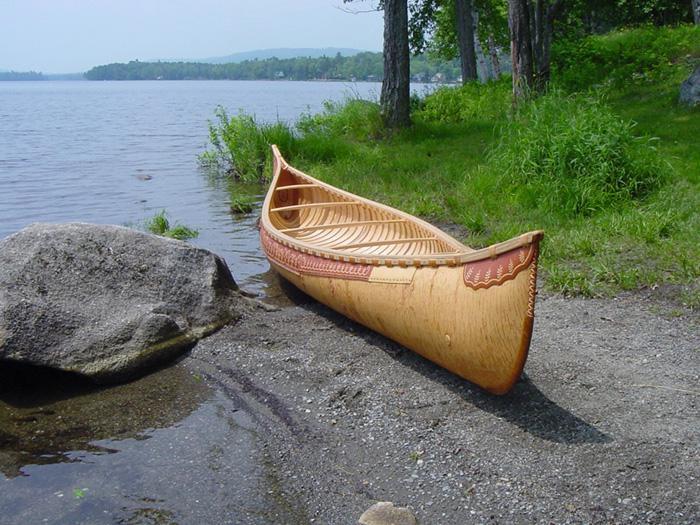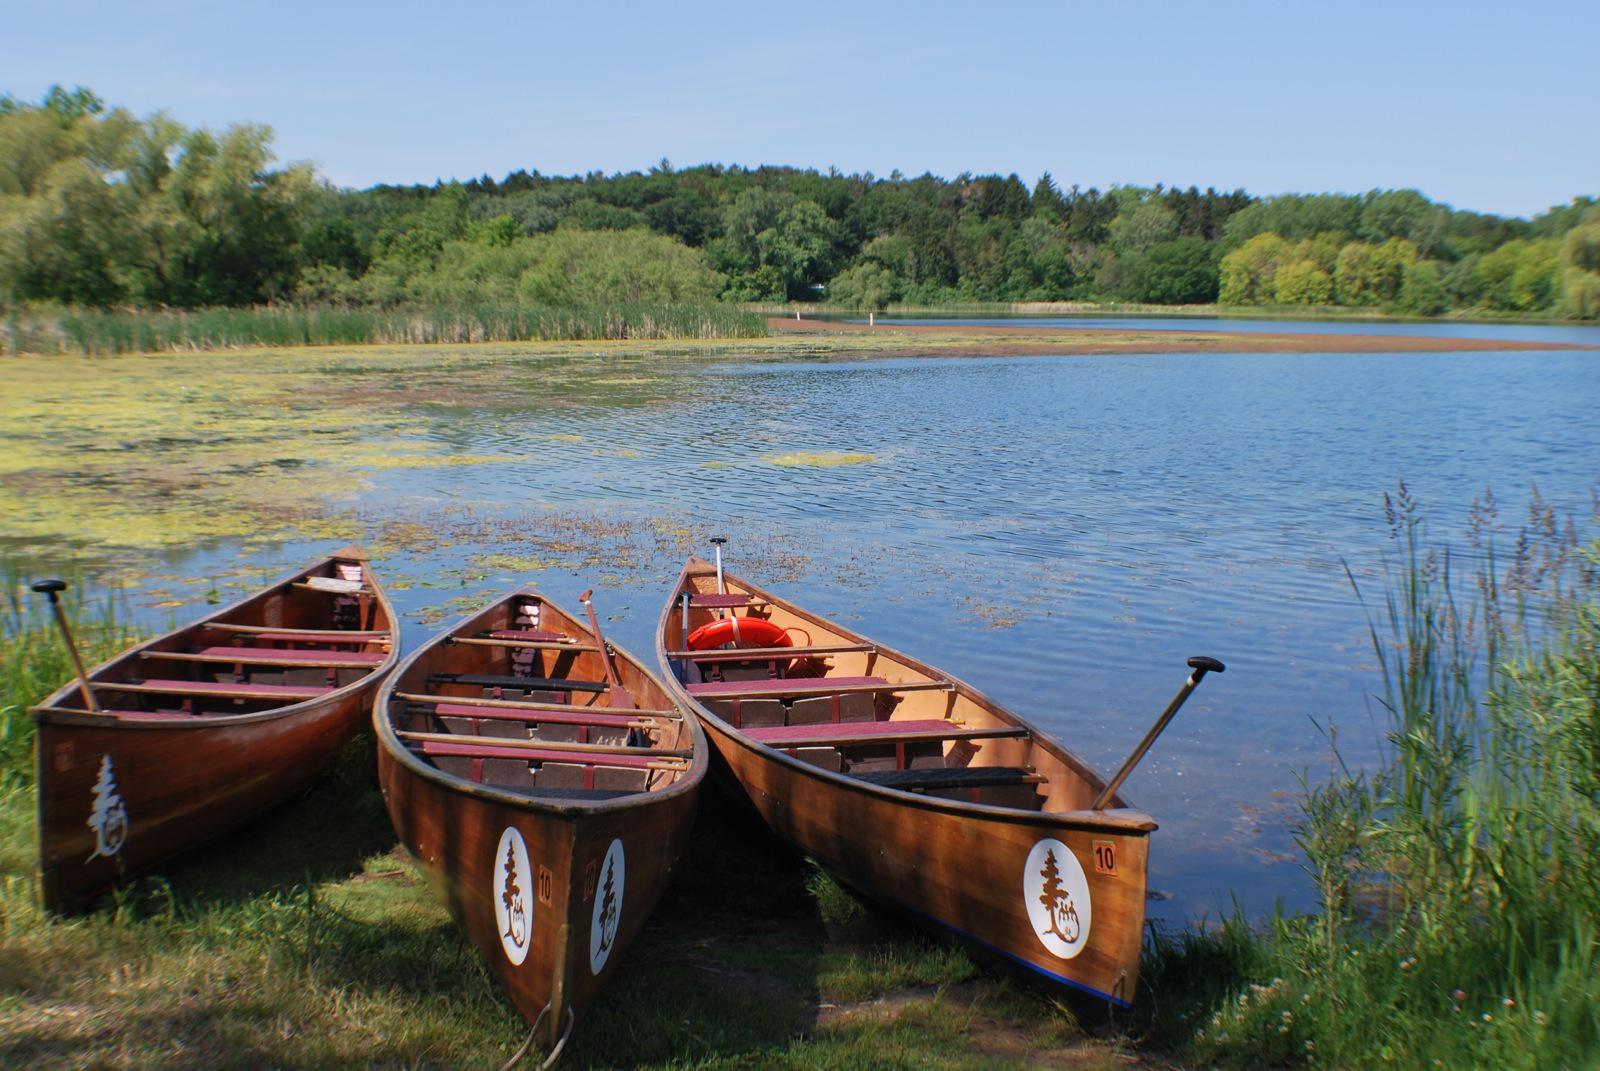The first image is the image on the left, the second image is the image on the right. Evaluate the accuracy of this statement regarding the images: "There are at least four boats in total.". Is it true? Answer yes or no. Yes. 